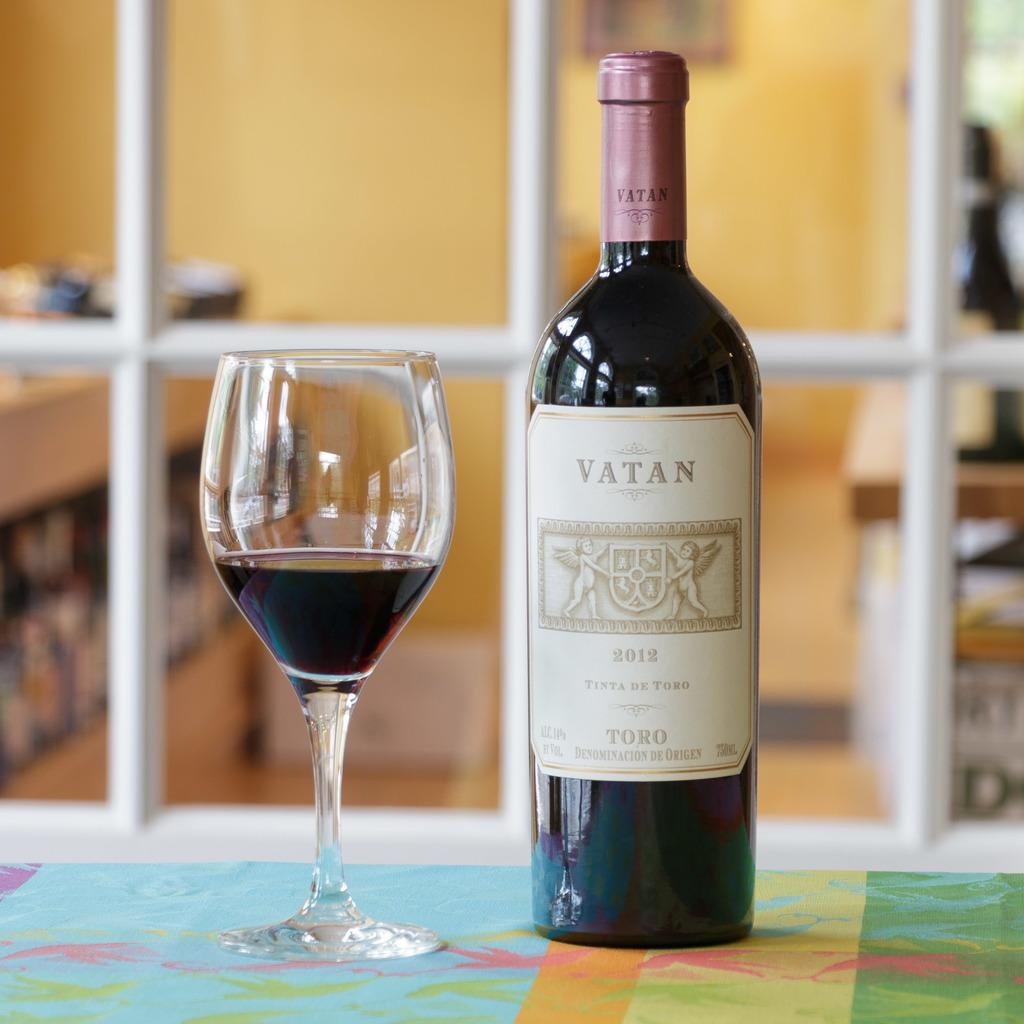<image>
Relay a brief, clear account of the picture shown. Bottle of Vatan Toro wine with a glass of wine 